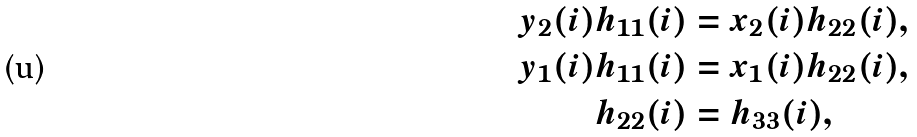<formula> <loc_0><loc_0><loc_500><loc_500>y _ { 2 } ( i ) h _ { 1 1 } ( i ) & = x _ { 2 } ( i ) h _ { 2 2 } ( i ) , \\ y _ { 1 } ( i ) h _ { 1 1 } ( i ) & = x _ { 1 } ( i ) h _ { 2 2 } ( i ) , \\ h _ { 2 2 } ( i ) & = h _ { 3 3 } ( i ) ,</formula> 